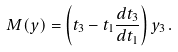<formula> <loc_0><loc_0><loc_500><loc_500>M ( y ) = \left ( t _ { 3 } - t _ { 1 } \frac { d t _ { 3 } } { d t _ { 1 } } \right ) y _ { 3 } \, .</formula> 